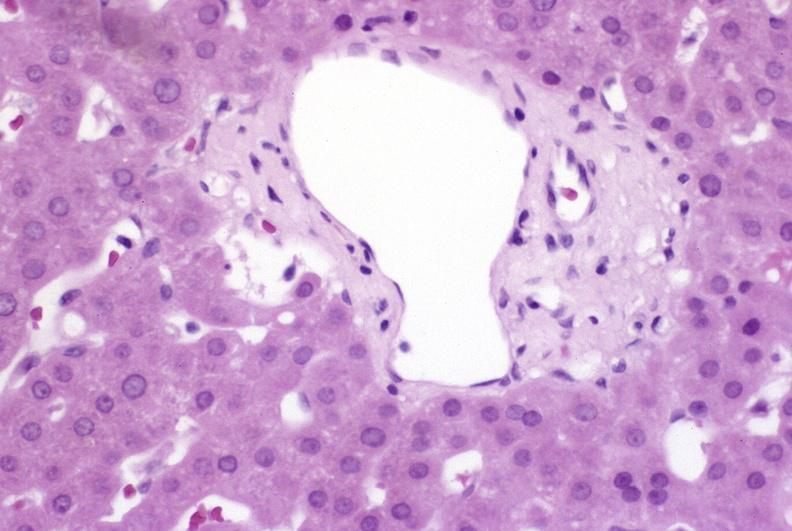what is present?
Answer the question using a single word or phrase. Hepatobiliary 